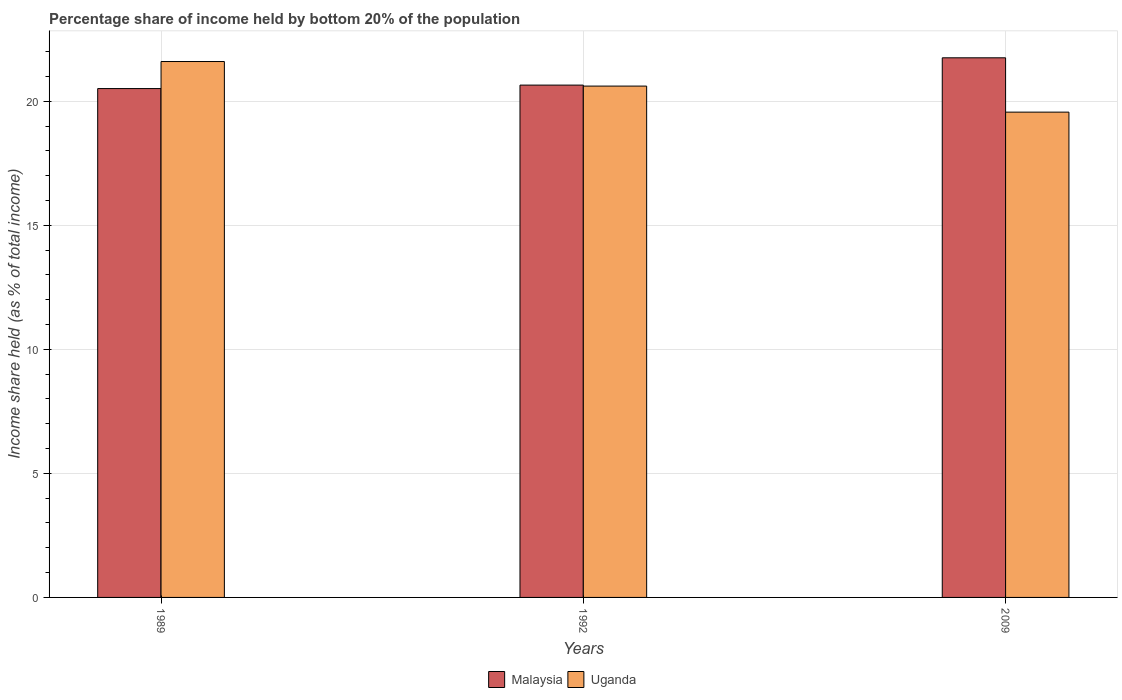Are the number of bars per tick equal to the number of legend labels?
Ensure brevity in your answer.  Yes. What is the label of the 3rd group of bars from the left?
Keep it short and to the point. 2009. What is the share of income held by bottom 20% of the population in Uganda in 2009?
Offer a very short reply. 19.56. Across all years, what is the maximum share of income held by bottom 20% of the population in Malaysia?
Provide a succinct answer. 21.75. Across all years, what is the minimum share of income held by bottom 20% of the population in Malaysia?
Offer a terse response. 20.51. What is the total share of income held by bottom 20% of the population in Malaysia in the graph?
Your response must be concise. 62.91. What is the difference between the share of income held by bottom 20% of the population in Malaysia in 1992 and that in 2009?
Ensure brevity in your answer.  -1.1. What is the difference between the share of income held by bottom 20% of the population in Uganda in 2009 and the share of income held by bottom 20% of the population in Malaysia in 1989?
Offer a terse response. -0.95. What is the average share of income held by bottom 20% of the population in Uganda per year?
Your answer should be compact. 20.59. In the year 2009, what is the difference between the share of income held by bottom 20% of the population in Malaysia and share of income held by bottom 20% of the population in Uganda?
Provide a short and direct response. 2.19. In how many years, is the share of income held by bottom 20% of the population in Malaysia greater than 13 %?
Offer a terse response. 3. What is the ratio of the share of income held by bottom 20% of the population in Uganda in 1989 to that in 1992?
Your answer should be compact. 1.05. Is the share of income held by bottom 20% of the population in Uganda in 1989 less than that in 2009?
Ensure brevity in your answer.  No. Is the difference between the share of income held by bottom 20% of the population in Malaysia in 1989 and 1992 greater than the difference between the share of income held by bottom 20% of the population in Uganda in 1989 and 1992?
Your answer should be compact. No. What is the difference between the highest and the second highest share of income held by bottom 20% of the population in Uganda?
Ensure brevity in your answer.  0.99. What is the difference between the highest and the lowest share of income held by bottom 20% of the population in Malaysia?
Offer a very short reply. 1.24. Is the sum of the share of income held by bottom 20% of the population in Uganda in 1989 and 1992 greater than the maximum share of income held by bottom 20% of the population in Malaysia across all years?
Your response must be concise. Yes. What does the 1st bar from the left in 1992 represents?
Your answer should be compact. Malaysia. What does the 1st bar from the right in 1992 represents?
Your answer should be compact. Uganda. Are all the bars in the graph horizontal?
Ensure brevity in your answer.  No. What is the difference between two consecutive major ticks on the Y-axis?
Your response must be concise. 5. Are the values on the major ticks of Y-axis written in scientific E-notation?
Your answer should be very brief. No. Does the graph contain any zero values?
Offer a very short reply. No. How many legend labels are there?
Give a very brief answer. 2. What is the title of the graph?
Offer a terse response. Percentage share of income held by bottom 20% of the population. Does "Jordan" appear as one of the legend labels in the graph?
Keep it short and to the point. No. What is the label or title of the X-axis?
Provide a short and direct response. Years. What is the label or title of the Y-axis?
Ensure brevity in your answer.  Income share held (as % of total income). What is the Income share held (as % of total income) of Malaysia in 1989?
Offer a terse response. 20.51. What is the Income share held (as % of total income) of Uganda in 1989?
Give a very brief answer. 21.6. What is the Income share held (as % of total income) of Malaysia in 1992?
Provide a succinct answer. 20.65. What is the Income share held (as % of total income) in Uganda in 1992?
Your response must be concise. 20.61. What is the Income share held (as % of total income) in Malaysia in 2009?
Provide a short and direct response. 21.75. What is the Income share held (as % of total income) of Uganda in 2009?
Keep it short and to the point. 19.56. Across all years, what is the maximum Income share held (as % of total income) of Malaysia?
Your answer should be very brief. 21.75. Across all years, what is the maximum Income share held (as % of total income) of Uganda?
Make the answer very short. 21.6. Across all years, what is the minimum Income share held (as % of total income) of Malaysia?
Your answer should be very brief. 20.51. Across all years, what is the minimum Income share held (as % of total income) in Uganda?
Provide a succinct answer. 19.56. What is the total Income share held (as % of total income) in Malaysia in the graph?
Provide a succinct answer. 62.91. What is the total Income share held (as % of total income) of Uganda in the graph?
Offer a very short reply. 61.77. What is the difference between the Income share held (as % of total income) of Malaysia in 1989 and that in 1992?
Ensure brevity in your answer.  -0.14. What is the difference between the Income share held (as % of total income) of Malaysia in 1989 and that in 2009?
Your answer should be compact. -1.24. What is the difference between the Income share held (as % of total income) of Uganda in 1989 and that in 2009?
Ensure brevity in your answer.  2.04. What is the difference between the Income share held (as % of total income) in Uganda in 1992 and that in 2009?
Make the answer very short. 1.05. What is the difference between the Income share held (as % of total income) in Malaysia in 1989 and the Income share held (as % of total income) in Uganda in 2009?
Make the answer very short. 0.95. What is the difference between the Income share held (as % of total income) of Malaysia in 1992 and the Income share held (as % of total income) of Uganda in 2009?
Provide a short and direct response. 1.09. What is the average Income share held (as % of total income) in Malaysia per year?
Provide a short and direct response. 20.97. What is the average Income share held (as % of total income) in Uganda per year?
Give a very brief answer. 20.59. In the year 1989, what is the difference between the Income share held (as % of total income) in Malaysia and Income share held (as % of total income) in Uganda?
Provide a short and direct response. -1.09. In the year 1992, what is the difference between the Income share held (as % of total income) of Malaysia and Income share held (as % of total income) of Uganda?
Your answer should be very brief. 0.04. In the year 2009, what is the difference between the Income share held (as % of total income) of Malaysia and Income share held (as % of total income) of Uganda?
Offer a very short reply. 2.19. What is the ratio of the Income share held (as % of total income) in Malaysia in 1989 to that in 1992?
Your response must be concise. 0.99. What is the ratio of the Income share held (as % of total income) in Uganda in 1989 to that in 1992?
Give a very brief answer. 1.05. What is the ratio of the Income share held (as % of total income) in Malaysia in 1989 to that in 2009?
Ensure brevity in your answer.  0.94. What is the ratio of the Income share held (as % of total income) in Uganda in 1989 to that in 2009?
Make the answer very short. 1.1. What is the ratio of the Income share held (as % of total income) in Malaysia in 1992 to that in 2009?
Your response must be concise. 0.95. What is the ratio of the Income share held (as % of total income) in Uganda in 1992 to that in 2009?
Ensure brevity in your answer.  1.05. What is the difference between the highest and the second highest Income share held (as % of total income) in Malaysia?
Your response must be concise. 1.1. What is the difference between the highest and the lowest Income share held (as % of total income) of Malaysia?
Your answer should be compact. 1.24. What is the difference between the highest and the lowest Income share held (as % of total income) in Uganda?
Your answer should be very brief. 2.04. 